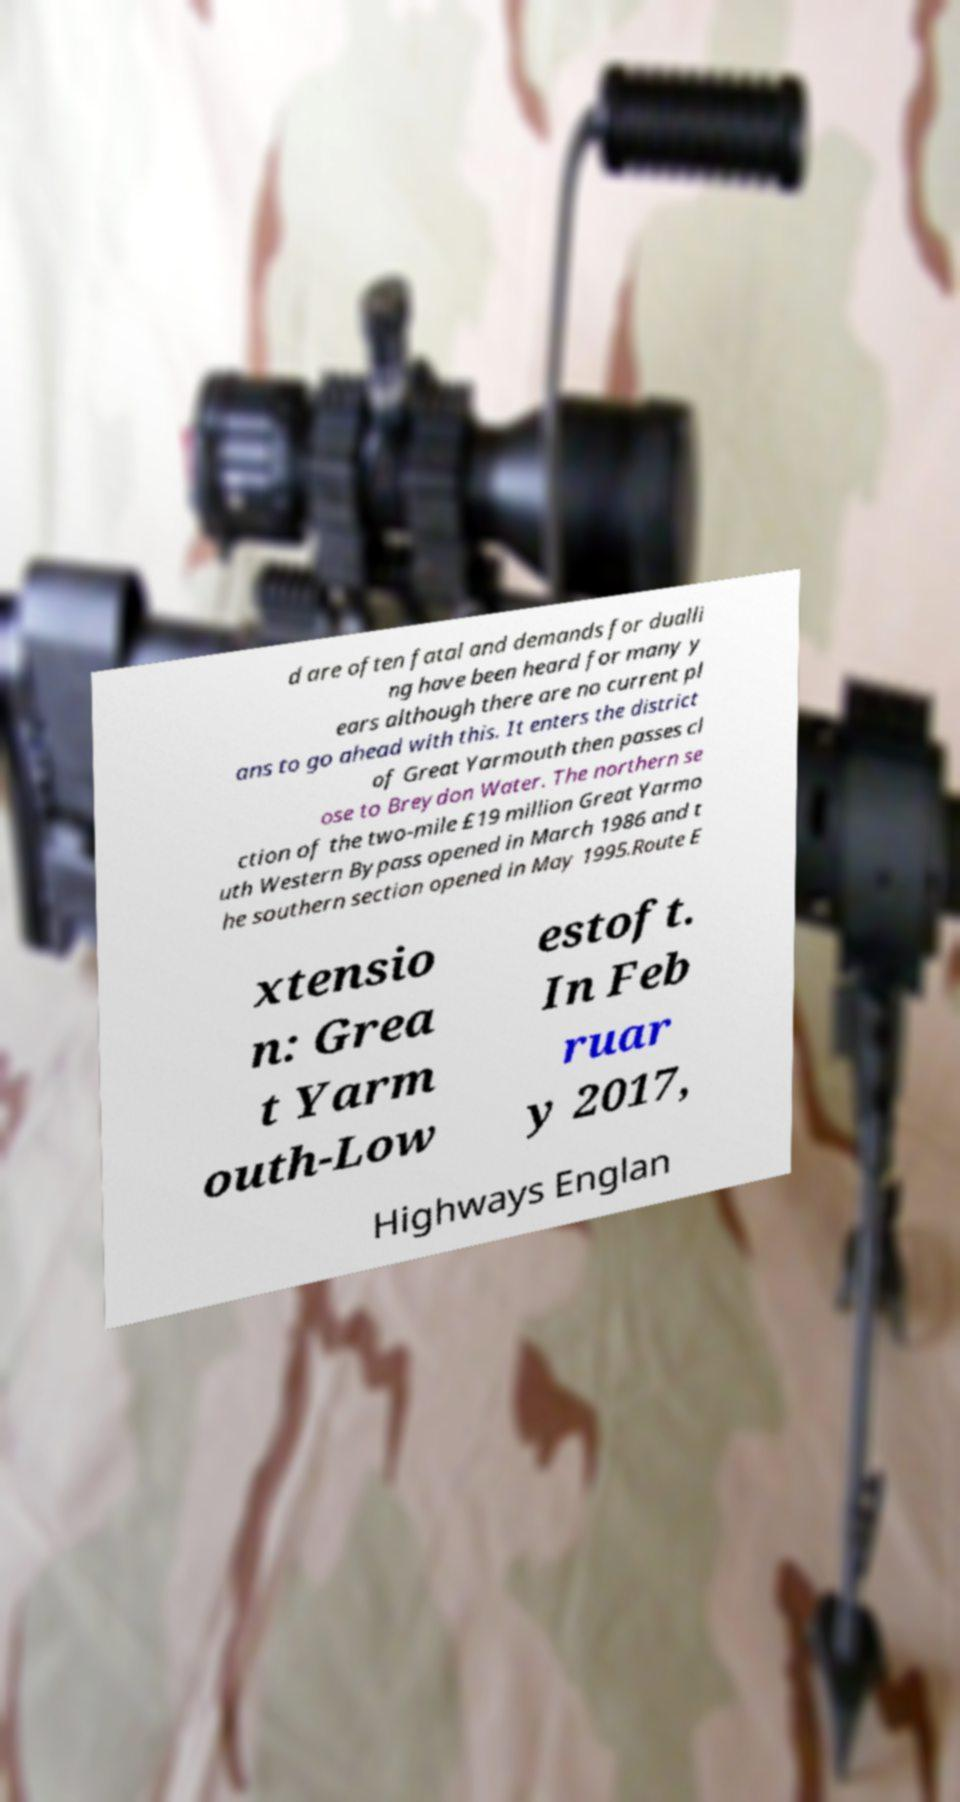Please identify and transcribe the text found in this image. d are often fatal and demands for dualli ng have been heard for many y ears although there are no current pl ans to go ahead with this. It enters the district of Great Yarmouth then passes cl ose to Breydon Water. The northern se ction of the two-mile £19 million Great Yarmo uth Western Bypass opened in March 1986 and t he southern section opened in May 1995.Route E xtensio n: Grea t Yarm outh-Low estoft. In Feb ruar y 2017, Highways Englan 